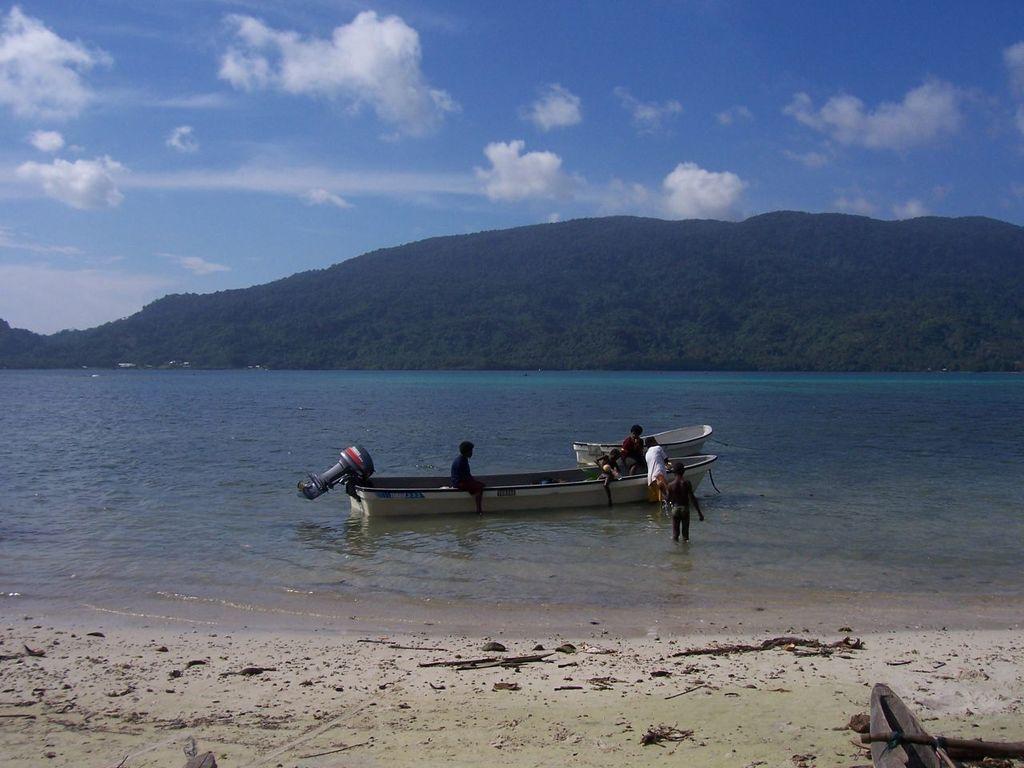Could you give a brief overview of what you see in this image? In the foreground of this image, on the bottom there is sand. In the background, there is water, a boat and few persons on it, a cliff, sky and the cloud. 